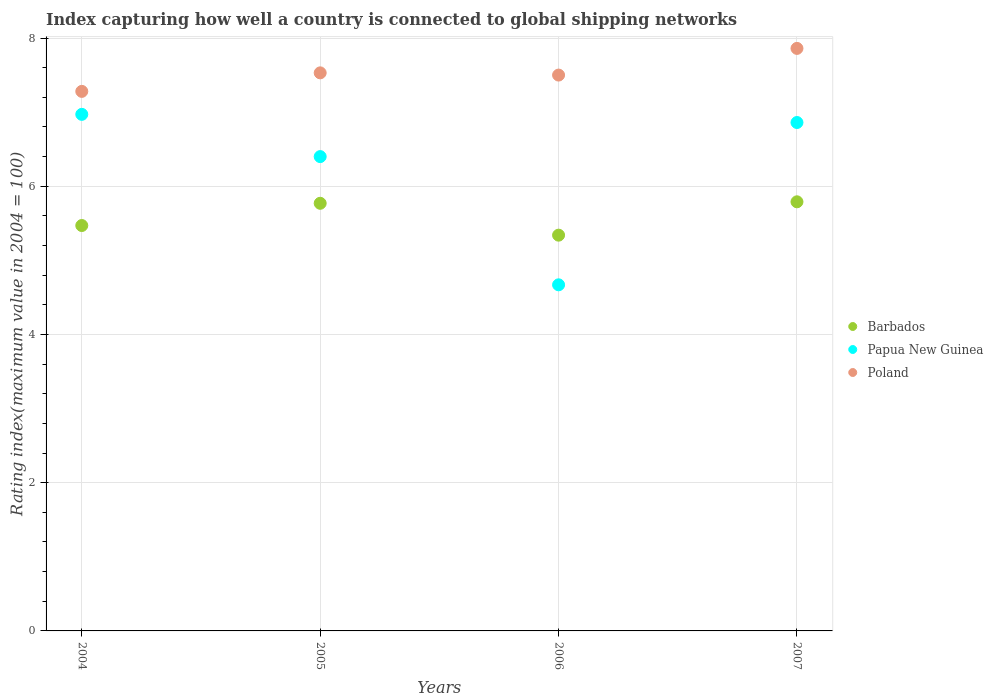How many different coloured dotlines are there?
Ensure brevity in your answer.  3. Is the number of dotlines equal to the number of legend labels?
Provide a succinct answer. Yes. What is the rating index in Barbados in 2007?
Your answer should be compact. 5.79. Across all years, what is the maximum rating index in Poland?
Your answer should be compact. 7.86. Across all years, what is the minimum rating index in Poland?
Your answer should be compact. 7.28. What is the total rating index in Papua New Guinea in the graph?
Make the answer very short. 24.9. What is the difference between the rating index in Papua New Guinea in 2004 and that in 2005?
Make the answer very short. 0.57. What is the difference between the rating index in Barbados in 2004 and the rating index in Poland in 2007?
Your answer should be very brief. -2.39. What is the average rating index in Poland per year?
Ensure brevity in your answer.  7.54. In the year 2007, what is the difference between the rating index in Papua New Guinea and rating index in Poland?
Ensure brevity in your answer.  -1. What is the ratio of the rating index in Papua New Guinea in 2004 to that in 2005?
Provide a succinct answer. 1.09. What is the difference between the highest and the second highest rating index in Barbados?
Provide a succinct answer. 0.02. What is the difference between the highest and the lowest rating index in Poland?
Provide a succinct answer. 0.58. In how many years, is the rating index in Barbados greater than the average rating index in Barbados taken over all years?
Provide a succinct answer. 2. Is it the case that in every year, the sum of the rating index in Papua New Guinea and rating index in Barbados  is greater than the rating index in Poland?
Keep it short and to the point. Yes. Does the rating index in Papua New Guinea monotonically increase over the years?
Ensure brevity in your answer.  No. Is the rating index in Poland strictly greater than the rating index in Papua New Guinea over the years?
Your answer should be very brief. Yes. Is the rating index in Papua New Guinea strictly less than the rating index in Poland over the years?
Ensure brevity in your answer.  Yes. How many years are there in the graph?
Your response must be concise. 4. What is the difference between two consecutive major ticks on the Y-axis?
Keep it short and to the point. 2. Are the values on the major ticks of Y-axis written in scientific E-notation?
Offer a very short reply. No. Does the graph contain grids?
Make the answer very short. Yes. How many legend labels are there?
Offer a very short reply. 3. How are the legend labels stacked?
Your answer should be compact. Vertical. What is the title of the graph?
Offer a very short reply. Index capturing how well a country is connected to global shipping networks. What is the label or title of the X-axis?
Offer a very short reply. Years. What is the label or title of the Y-axis?
Your answer should be compact. Rating index(maximum value in 2004 = 100). What is the Rating index(maximum value in 2004 = 100) in Barbados in 2004?
Your response must be concise. 5.47. What is the Rating index(maximum value in 2004 = 100) of Papua New Guinea in 2004?
Your response must be concise. 6.97. What is the Rating index(maximum value in 2004 = 100) in Poland in 2004?
Ensure brevity in your answer.  7.28. What is the Rating index(maximum value in 2004 = 100) in Barbados in 2005?
Ensure brevity in your answer.  5.77. What is the Rating index(maximum value in 2004 = 100) in Papua New Guinea in 2005?
Give a very brief answer. 6.4. What is the Rating index(maximum value in 2004 = 100) in Poland in 2005?
Your response must be concise. 7.53. What is the Rating index(maximum value in 2004 = 100) in Barbados in 2006?
Your answer should be compact. 5.34. What is the Rating index(maximum value in 2004 = 100) in Papua New Guinea in 2006?
Ensure brevity in your answer.  4.67. What is the Rating index(maximum value in 2004 = 100) of Poland in 2006?
Ensure brevity in your answer.  7.5. What is the Rating index(maximum value in 2004 = 100) in Barbados in 2007?
Keep it short and to the point. 5.79. What is the Rating index(maximum value in 2004 = 100) of Papua New Guinea in 2007?
Your response must be concise. 6.86. What is the Rating index(maximum value in 2004 = 100) of Poland in 2007?
Offer a very short reply. 7.86. Across all years, what is the maximum Rating index(maximum value in 2004 = 100) of Barbados?
Offer a terse response. 5.79. Across all years, what is the maximum Rating index(maximum value in 2004 = 100) of Papua New Guinea?
Your answer should be very brief. 6.97. Across all years, what is the maximum Rating index(maximum value in 2004 = 100) of Poland?
Ensure brevity in your answer.  7.86. Across all years, what is the minimum Rating index(maximum value in 2004 = 100) in Barbados?
Offer a terse response. 5.34. Across all years, what is the minimum Rating index(maximum value in 2004 = 100) in Papua New Guinea?
Your response must be concise. 4.67. Across all years, what is the minimum Rating index(maximum value in 2004 = 100) in Poland?
Keep it short and to the point. 7.28. What is the total Rating index(maximum value in 2004 = 100) in Barbados in the graph?
Provide a short and direct response. 22.37. What is the total Rating index(maximum value in 2004 = 100) of Papua New Guinea in the graph?
Provide a short and direct response. 24.9. What is the total Rating index(maximum value in 2004 = 100) of Poland in the graph?
Your answer should be very brief. 30.17. What is the difference between the Rating index(maximum value in 2004 = 100) in Barbados in 2004 and that in 2005?
Offer a terse response. -0.3. What is the difference between the Rating index(maximum value in 2004 = 100) in Papua New Guinea in 2004 and that in 2005?
Provide a succinct answer. 0.57. What is the difference between the Rating index(maximum value in 2004 = 100) in Barbados in 2004 and that in 2006?
Make the answer very short. 0.13. What is the difference between the Rating index(maximum value in 2004 = 100) of Poland in 2004 and that in 2006?
Make the answer very short. -0.22. What is the difference between the Rating index(maximum value in 2004 = 100) in Barbados in 2004 and that in 2007?
Give a very brief answer. -0.32. What is the difference between the Rating index(maximum value in 2004 = 100) of Papua New Guinea in 2004 and that in 2007?
Provide a short and direct response. 0.11. What is the difference between the Rating index(maximum value in 2004 = 100) of Poland in 2004 and that in 2007?
Your answer should be very brief. -0.58. What is the difference between the Rating index(maximum value in 2004 = 100) of Barbados in 2005 and that in 2006?
Your response must be concise. 0.43. What is the difference between the Rating index(maximum value in 2004 = 100) in Papua New Guinea in 2005 and that in 2006?
Your answer should be very brief. 1.73. What is the difference between the Rating index(maximum value in 2004 = 100) in Poland in 2005 and that in 2006?
Provide a short and direct response. 0.03. What is the difference between the Rating index(maximum value in 2004 = 100) in Barbados in 2005 and that in 2007?
Your response must be concise. -0.02. What is the difference between the Rating index(maximum value in 2004 = 100) in Papua New Guinea in 2005 and that in 2007?
Make the answer very short. -0.46. What is the difference between the Rating index(maximum value in 2004 = 100) in Poland in 2005 and that in 2007?
Provide a succinct answer. -0.33. What is the difference between the Rating index(maximum value in 2004 = 100) in Barbados in 2006 and that in 2007?
Provide a succinct answer. -0.45. What is the difference between the Rating index(maximum value in 2004 = 100) of Papua New Guinea in 2006 and that in 2007?
Provide a short and direct response. -2.19. What is the difference between the Rating index(maximum value in 2004 = 100) of Poland in 2006 and that in 2007?
Your answer should be compact. -0.36. What is the difference between the Rating index(maximum value in 2004 = 100) of Barbados in 2004 and the Rating index(maximum value in 2004 = 100) of Papua New Guinea in 2005?
Ensure brevity in your answer.  -0.93. What is the difference between the Rating index(maximum value in 2004 = 100) of Barbados in 2004 and the Rating index(maximum value in 2004 = 100) of Poland in 2005?
Your answer should be very brief. -2.06. What is the difference between the Rating index(maximum value in 2004 = 100) of Papua New Guinea in 2004 and the Rating index(maximum value in 2004 = 100) of Poland in 2005?
Offer a terse response. -0.56. What is the difference between the Rating index(maximum value in 2004 = 100) in Barbados in 2004 and the Rating index(maximum value in 2004 = 100) in Poland in 2006?
Provide a short and direct response. -2.03. What is the difference between the Rating index(maximum value in 2004 = 100) of Papua New Guinea in 2004 and the Rating index(maximum value in 2004 = 100) of Poland in 2006?
Offer a very short reply. -0.53. What is the difference between the Rating index(maximum value in 2004 = 100) in Barbados in 2004 and the Rating index(maximum value in 2004 = 100) in Papua New Guinea in 2007?
Give a very brief answer. -1.39. What is the difference between the Rating index(maximum value in 2004 = 100) in Barbados in 2004 and the Rating index(maximum value in 2004 = 100) in Poland in 2007?
Offer a very short reply. -2.39. What is the difference between the Rating index(maximum value in 2004 = 100) in Papua New Guinea in 2004 and the Rating index(maximum value in 2004 = 100) in Poland in 2007?
Provide a succinct answer. -0.89. What is the difference between the Rating index(maximum value in 2004 = 100) of Barbados in 2005 and the Rating index(maximum value in 2004 = 100) of Papua New Guinea in 2006?
Your response must be concise. 1.1. What is the difference between the Rating index(maximum value in 2004 = 100) in Barbados in 2005 and the Rating index(maximum value in 2004 = 100) in Poland in 2006?
Give a very brief answer. -1.73. What is the difference between the Rating index(maximum value in 2004 = 100) of Papua New Guinea in 2005 and the Rating index(maximum value in 2004 = 100) of Poland in 2006?
Offer a terse response. -1.1. What is the difference between the Rating index(maximum value in 2004 = 100) in Barbados in 2005 and the Rating index(maximum value in 2004 = 100) in Papua New Guinea in 2007?
Give a very brief answer. -1.09. What is the difference between the Rating index(maximum value in 2004 = 100) of Barbados in 2005 and the Rating index(maximum value in 2004 = 100) of Poland in 2007?
Offer a very short reply. -2.09. What is the difference between the Rating index(maximum value in 2004 = 100) in Papua New Guinea in 2005 and the Rating index(maximum value in 2004 = 100) in Poland in 2007?
Make the answer very short. -1.46. What is the difference between the Rating index(maximum value in 2004 = 100) of Barbados in 2006 and the Rating index(maximum value in 2004 = 100) of Papua New Guinea in 2007?
Offer a very short reply. -1.52. What is the difference between the Rating index(maximum value in 2004 = 100) in Barbados in 2006 and the Rating index(maximum value in 2004 = 100) in Poland in 2007?
Your answer should be compact. -2.52. What is the difference between the Rating index(maximum value in 2004 = 100) of Papua New Guinea in 2006 and the Rating index(maximum value in 2004 = 100) of Poland in 2007?
Your answer should be compact. -3.19. What is the average Rating index(maximum value in 2004 = 100) in Barbados per year?
Give a very brief answer. 5.59. What is the average Rating index(maximum value in 2004 = 100) of Papua New Guinea per year?
Your response must be concise. 6.22. What is the average Rating index(maximum value in 2004 = 100) in Poland per year?
Give a very brief answer. 7.54. In the year 2004, what is the difference between the Rating index(maximum value in 2004 = 100) of Barbados and Rating index(maximum value in 2004 = 100) of Papua New Guinea?
Provide a succinct answer. -1.5. In the year 2004, what is the difference between the Rating index(maximum value in 2004 = 100) of Barbados and Rating index(maximum value in 2004 = 100) of Poland?
Your response must be concise. -1.81. In the year 2004, what is the difference between the Rating index(maximum value in 2004 = 100) of Papua New Guinea and Rating index(maximum value in 2004 = 100) of Poland?
Your answer should be very brief. -0.31. In the year 2005, what is the difference between the Rating index(maximum value in 2004 = 100) of Barbados and Rating index(maximum value in 2004 = 100) of Papua New Guinea?
Your answer should be very brief. -0.63. In the year 2005, what is the difference between the Rating index(maximum value in 2004 = 100) in Barbados and Rating index(maximum value in 2004 = 100) in Poland?
Keep it short and to the point. -1.76. In the year 2005, what is the difference between the Rating index(maximum value in 2004 = 100) in Papua New Guinea and Rating index(maximum value in 2004 = 100) in Poland?
Give a very brief answer. -1.13. In the year 2006, what is the difference between the Rating index(maximum value in 2004 = 100) of Barbados and Rating index(maximum value in 2004 = 100) of Papua New Guinea?
Your answer should be very brief. 0.67. In the year 2006, what is the difference between the Rating index(maximum value in 2004 = 100) in Barbados and Rating index(maximum value in 2004 = 100) in Poland?
Provide a short and direct response. -2.16. In the year 2006, what is the difference between the Rating index(maximum value in 2004 = 100) of Papua New Guinea and Rating index(maximum value in 2004 = 100) of Poland?
Provide a succinct answer. -2.83. In the year 2007, what is the difference between the Rating index(maximum value in 2004 = 100) in Barbados and Rating index(maximum value in 2004 = 100) in Papua New Guinea?
Offer a very short reply. -1.07. In the year 2007, what is the difference between the Rating index(maximum value in 2004 = 100) of Barbados and Rating index(maximum value in 2004 = 100) of Poland?
Make the answer very short. -2.07. What is the ratio of the Rating index(maximum value in 2004 = 100) in Barbados in 2004 to that in 2005?
Your answer should be compact. 0.95. What is the ratio of the Rating index(maximum value in 2004 = 100) of Papua New Guinea in 2004 to that in 2005?
Offer a very short reply. 1.09. What is the ratio of the Rating index(maximum value in 2004 = 100) of Poland in 2004 to that in 2005?
Give a very brief answer. 0.97. What is the ratio of the Rating index(maximum value in 2004 = 100) in Barbados in 2004 to that in 2006?
Ensure brevity in your answer.  1.02. What is the ratio of the Rating index(maximum value in 2004 = 100) in Papua New Guinea in 2004 to that in 2006?
Provide a succinct answer. 1.49. What is the ratio of the Rating index(maximum value in 2004 = 100) in Poland in 2004 to that in 2006?
Ensure brevity in your answer.  0.97. What is the ratio of the Rating index(maximum value in 2004 = 100) of Barbados in 2004 to that in 2007?
Your answer should be compact. 0.94. What is the ratio of the Rating index(maximum value in 2004 = 100) of Poland in 2004 to that in 2007?
Provide a succinct answer. 0.93. What is the ratio of the Rating index(maximum value in 2004 = 100) of Barbados in 2005 to that in 2006?
Ensure brevity in your answer.  1.08. What is the ratio of the Rating index(maximum value in 2004 = 100) of Papua New Guinea in 2005 to that in 2006?
Provide a short and direct response. 1.37. What is the ratio of the Rating index(maximum value in 2004 = 100) in Papua New Guinea in 2005 to that in 2007?
Your answer should be very brief. 0.93. What is the ratio of the Rating index(maximum value in 2004 = 100) in Poland in 2005 to that in 2007?
Offer a very short reply. 0.96. What is the ratio of the Rating index(maximum value in 2004 = 100) in Barbados in 2006 to that in 2007?
Offer a very short reply. 0.92. What is the ratio of the Rating index(maximum value in 2004 = 100) in Papua New Guinea in 2006 to that in 2007?
Ensure brevity in your answer.  0.68. What is the ratio of the Rating index(maximum value in 2004 = 100) in Poland in 2006 to that in 2007?
Provide a succinct answer. 0.95. What is the difference between the highest and the second highest Rating index(maximum value in 2004 = 100) in Barbados?
Ensure brevity in your answer.  0.02. What is the difference between the highest and the second highest Rating index(maximum value in 2004 = 100) in Papua New Guinea?
Your answer should be very brief. 0.11. What is the difference between the highest and the second highest Rating index(maximum value in 2004 = 100) of Poland?
Offer a very short reply. 0.33. What is the difference between the highest and the lowest Rating index(maximum value in 2004 = 100) of Barbados?
Provide a short and direct response. 0.45. What is the difference between the highest and the lowest Rating index(maximum value in 2004 = 100) in Poland?
Your answer should be very brief. 0.58. 